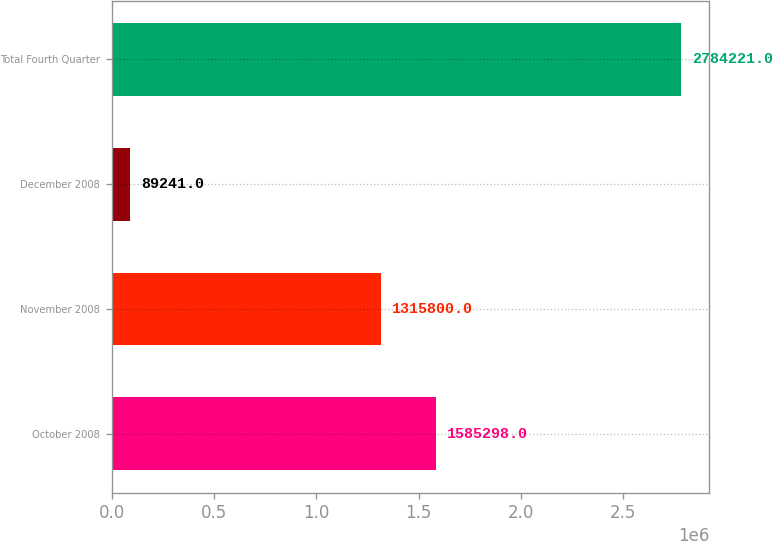Convert chart to OTSL. <chart><loc_0><loc_0><loc_500><loc_500><bar_chart><fcel>October 2008<fcel>November 2008<fcel>December 2008<fcel>Total Fourth Quarter<nl><fcel>1.5853e+06<fcel>1.3158e+06<fcel>89241<fcel>2.78422e+06<nl></chart> 